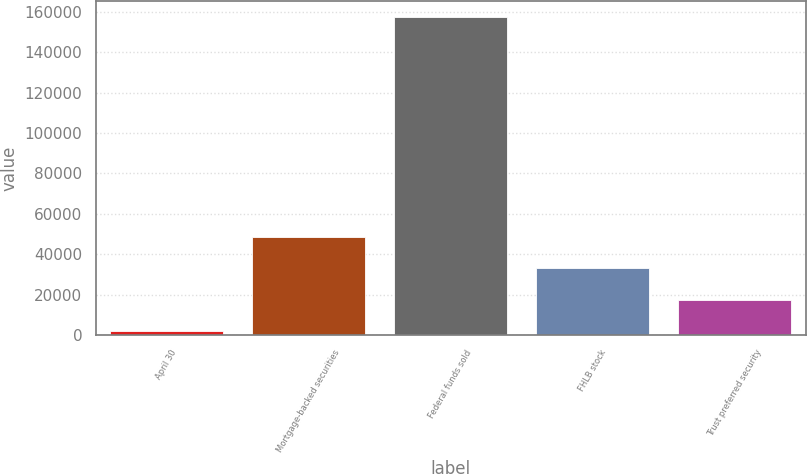Convert chart. <chart><loc_0><loc_0><loc_500><loc_500><bar_chart><fcel>April 30<fcel>Mortgage-backed securities<fcel>Federal funds sold<fcel>FHLB stock<fcel>Trust preferred security<nl><fcel>2009<fcel>48604.1<fcel>157326<fcel>33072.4<fcel>17540.7<nl></chart> 